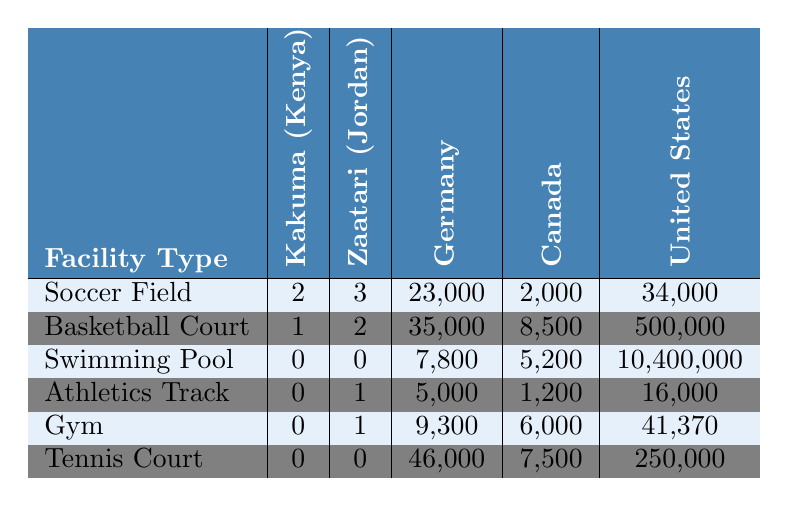What is the total number of soccer fields in both Kakuma and Zaatari refugee camps? To find the total number of soccer fields, we add the number of fields in Kakuma (2) and Zaatari (3): 2 + 3 = 5.
Answer: 5 How many basketball courts are available in the United States compared to the Zaatari Refugee Camp? The United States has 500,000 basketball courts while the Zaatari Refugee Camp has 2. The answer is that the U.S. has significantly more, specifically 499,998 more than Zaatari.
Answer: 499,998 more Does Kakuma Refugee Camp have any swimming pools? The table shows 0 swimming pools in Kakuma Refugee Camp. Therefore, the answer is no.
Answer: No What is the average number of gym facilities across the listed countries? To find the average number of gyms, add the values: 0 (Kakuma) + 1 (Zaatari) + 9300 (Germany) + 6000 (Canada) + 41370 (U.S.) = 50371. Then divide by 5, which equals 10074.2.
Answer: 10074.2 Which country has the highest number of tennis courts and how many do they have? According to the table, the United States has the highest number of tennis courts at 250,000.
Answer: 250,000 in the United States If we consider both refugee camps, how many athletics tracks do they have in total? Kakuma has 0 athletics tracks and Zaatari has 1, so the total is 0 + 1 = 1.
Answer: 1 Is it true that Kakuma has more basketball courts than Zaatari? Kakuma has 1 basketball court and Zaatari has 2. Therefore, the statement is false.
Answer: False What is the difference in the number of swimming pools between the United States and Zaatari? The United States has 10,400,000 swimming pools and Zaatari has 0. The difference is 10,400,000 - 0 = 10,400,000.
Answer: 10,400,000 What percentage of basketball courts in Canada does the total number of basketball courts in the Zaatari Refugee Camp represent? The Zaatari camp has 2 basketball courts and Canada has 8,500. To find the percentage, divide 2 by 8,500 and multiply by 100: (2 / 8500) * 100 ≈ 0.0235%.
Answer: 0.0235% How many more soccer fields are there in Germany than in Kakuma? Germany has 23,000 soccer fields and Kakuma has 2. So, the difference is 23,000 - 2 = 22,998.
Answer: 22,998 more What is the maximum number of sports facilities that any country or camp has for a single type of facility? By checking the table, the maximum is 10,400,000 swimming pools in the United States.
Answer: 10,400,000 